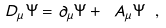<formula> <loc_0><loc_0><loc_500><loc_500>\ D _ { \mu } \Psi = \partial _ { \mu } \Psi + \ A _ { \mu } \Psi \ ,</formula> 